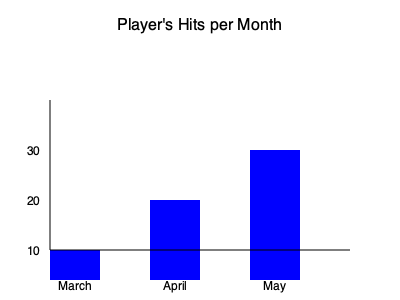As a tech-savvy baseball parent, you're analyzing a player's performance using the bar graph above. If the player had 100 at-bats each month, what would be their batting average for the entire three-month period? To calculate the player's batting average for the three-month period, we'll follow these steps:

1. Determine the number of hits for each month:
   - March: 10 hits
   - April: 20 hits
   - May: 30 hits

2. Calculate the total number of hits:
   $10 + 20 + 30 = 60$ hits

3. Calculate the total number of at-bats:
   $100$ at-bats per month $\times 3$ months $= 300$ at-bats

4. Use the batting average formula:
   Batting Average $= \frac{\text{Number of Hits}}{\text{Number of At-Bats}}$

5. Plug in the values:
   Batting Average $= \frac{60}{300}$

6. Simplify the fraction:
   $\frac{60}{300} = \frac{1}{5} = 0.200$

Therefore, the player's batting average for the three-month period is 0.200 or .200 when expressed in baseball notation.
Answer: .200 